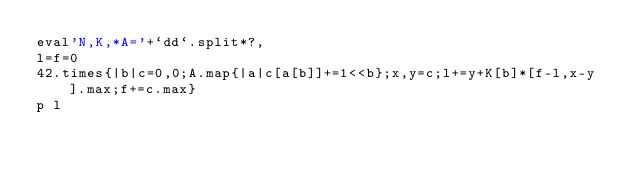Convert code to text. <code><loc_0><loc_0><loc_500><loc_500><_Ruby_>eval'N,K,*A='+`dd`.split*?,
l=f=0
42.times{|b|c=0,0;A.map{|a|c[a[b]]+=1<<b};x,y=c;l+=y+K[b]*[f-l,x-y].max;f+=c.max}
p l</code> 